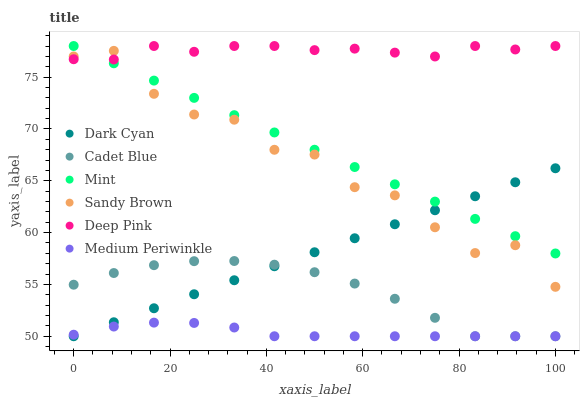Does Medium Periwinkle have the minimum area under the curve?
Answer yes or no. Yes. Does Deep Pink have the maximum area under the curve?
Answer yes or no. Yes. Does Mint have the minimum area under the curve?
Answer yes or no. No. Does Mint have the maximum area under the curve?
Answer yes or no. No. Is Mint the smoothest?
Answer yes or no. Yes. Is Sandy Brown the roughest?
Answer yes or no. Yes. Is Medium Periwinkle the smoothest?
Answer yes or no. No. Is Medium Periwinkle the roughest?
Answer yes or no. No. Does Cadet Blue have the lowest value?
Answer yes or no. Yes. Does Mint have the lowest value?
Answer yes or no. No. Does Deep Pink have the highest value?
Answer yes or no. Yes. Does Medium Periwinkle have the highest value?
Answer yes or no. No. Is Cadet Blue less than Mint?
Answer yes or no. Yes. Is Sandy Brown greater than Cadet Blue?
Answer yes or no. Yes. Does Mint intersect Deep Pink?
Answer yes or no. Yes. Is Mint less than Deep Pink?
Answer yes or no. No. Is Mint greater than Deep Pink?
Answer yes or no. No. Does Cadet Blue intersect Mint?
Answer yes or no. No. 